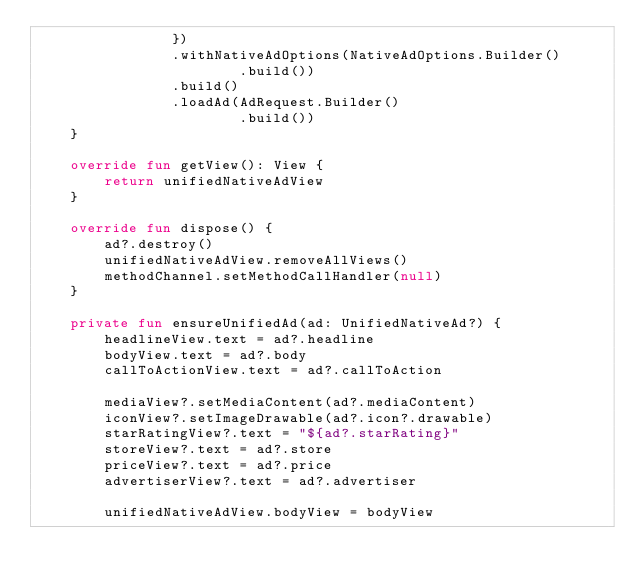Convert code to text. <code><loc_0><loc_0><loc_500><loc_500><_Kotlin_>                })
                .withNativeAdOptions(NativeAdOptions.Builder()
                        .build())
                .build()
                .loadAd(AdRequest.Builder()
                        .build())
    }

    override fun getView(): View {
        return unifiedNativeAdView
    }

    override fun dispose() {
        ad?.destroy()
        unifiedNativeAdView.removeAllViews()
        methodChannel.setMethodCallHandler(null)
    }

    private fun ensureUnifiedAd(ad: UnifiedNativeAd?) {
        headlineView.text = ad?.headline
        bodyView.text = ad?.body
        callToActionView.text = ad?.callToAction

        mediaView?.setMediaContent(ad?.mediaContent)
        iconView?.setImageDrawable(ad?.icon?.drawable)
        starRatingView?.text = "${ad?.starRating}"
        storeView?.text = ad?.store
        priceView?.text = ad?.price
        advertiserView?.text = ad?.advertiser

        unifiedNativeAdView.bodyView = bodyView</code> 